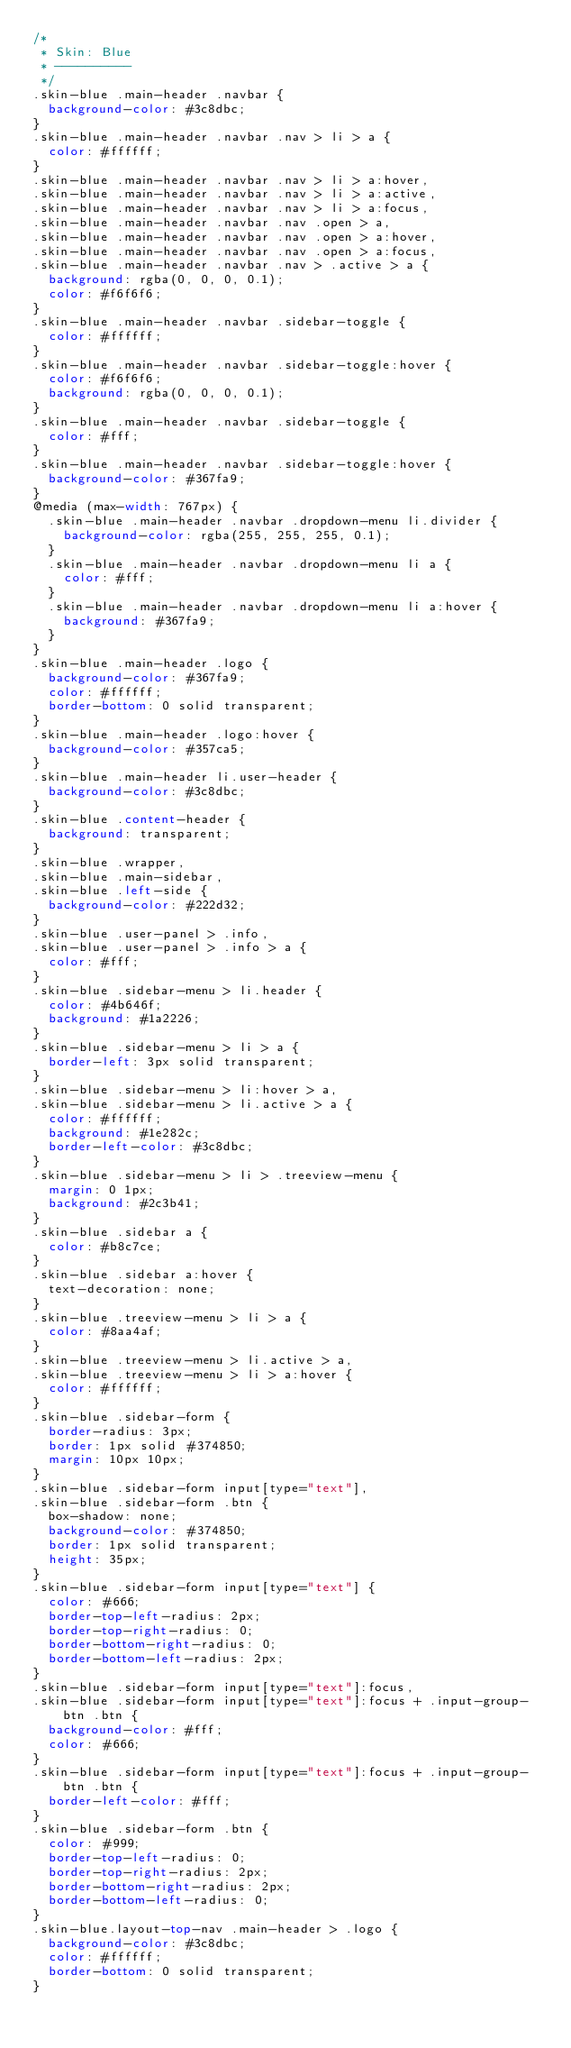<code> <loc_0><loc_0><loc_500><loc_500><_CSS_>/*
 * Skin: Blue
 * ----------
 */
.skin-blue .main-header .navbar {
  background-color: #3c8dbc;
}
.skin-blue .main-header .navbar .nav > li > a {
  color: #ffffff;
}
.skin-blue .main-header .navbar .nav > li > a:hover,
.skin-blue .main-header .navbar .nav > li > a:active,
.skin-blue .main-header .navbar .nav > li > a:focus,
.skin-blue .main-header .navbar .nav .open > a,
.skin-blue .main-header .navbar .nav .open > a:hover,
.skin-blue .main-header .navbar .nav .open > a:focus,
.skin-blue .main-header .navbar .nav > .active > a {
  background: rgba(0, 0, 0, 0.1);
  color: #f6f6f6;
}
.skin-blue .main-header .navbar .sidebar-toggle {
  color: #ffffff;
}
.skin-blue .main-header .navbar .sidebar-toggle:hover {
  color: #f6f6f6;
  background: rgba(0, 0, 0, 0.1);
}
.skin-blue .main-header .navbar .sidebar-toggle {
  color: #fff;
}
.skin-blue .main-header .navbar .sidebar-toggle:hover {
  background-color: #367fa9;
}
@media (max-width: 767px) {
  .skin-blue .main-header .navbar .dropdown-menu li.divider {
    background-color: rgba(255, 255, 255, 0.1);
  }
  .skin-blue .main-header .navbar .dropdown-menu li a {
    color: #fff;
  }
  .skin-blue .main-header .navbar .dropdown-menu li a:hover {
    background: #367fa9;
  }
}
.skin-blue .main-header .logo {
  background-color: #367fa9;
  color: #ffffff;
  border-bottom: 0 solid transparent;
}
.skin-blue .main-header .logo:hover {
  background-color: #357ca5;
}
.skin-blue .main-header li.user-header {
  background-color: #3c8dbc;
}
.skin-blue .content-header {
  background: transparent;
}
.skin-blue .wrapper,
.skin-blue .main-sidebar,
.skin-blue .left-side {
  background-color: #222d32;
}
.skin-blue .user-panel > .info,
.skin-blue .user-panel > .info > a {
  color: #fff;
}
.skin-blue .sidebar-menu > li.header {
  color: #4b646f;
  background: #1a2226;
}
.skin-blue .sidebar-menu > li > a {
  border-left: 3px solid transparent;
}
.skin-blue .sidebar-menu > li:hover > a,
.skin-blue .sidebar-menu > li.active > a {
  color: #ffffff;
  background: #1e282c;
  border-left-color: #3c8dbc;
}
.skin-blue .sidebar-menu > li > .treeview-menu {
  margin: 0 1px;
  background: #2c3b41;
}
.skin-blue .sidebar a {
  color: #b8c7ce;
}
.skin-blue .sidebar a:hover {
  text-decoration: none;
}
.skin-blue .treeview-menu > li > a {
  color: #8aa4af;
}
.skin-blue .treeview-menu > li.active > a,
.skin-blue .treeview-menu > li > a:hover {
  color: #ffffff;
}
.skin-blue .sidebar-form {
  border-radius: 3px;
  border: 1px solid #374850;
  margin: 10px 10px;
}
.skin-blue .sidebar-form input[type="text"],
.skin-blue .sidebar-form .btn {
  box-shadow: none;
  background-color: #374850;
  border: 1px solid transparent;
  height: 35px;
}
.skin-blue .sidebar-form input[type="text"] {
  color: #666;
  border-top-left-radius: 2px;
  border-top-right-radius: 0;
  border-bottom-right-radius: 0;
  border-bottom-left-radius: 2px;
}
.skin-blue .sidebar-form input[type="text"]:focus,
.skin-blue .sidebar-form input[type="text"]:focus + .input-group-btn .btn {
  background-color: #fff;
  color: #666;
}
.skin-blue .sidebar-form input[type="text"]:focus + .input-group-btn .btn {
  border-left-color: #fff;
}
.skin-blue .sidebar-form .btn {
  color: #999;
  border-top-left-radius: 0;
  border-top-right-radius: 2px;
  border-bottom-right-radius: 2px;
  border-bottom-left-radius: 0;
}
.skin-blue.layout-top-nav .main-header > .logo {
  background-color: #3c8dbc;
  color: #ffffff;
  border-bottom: 0 solid transparent;
}</code> 